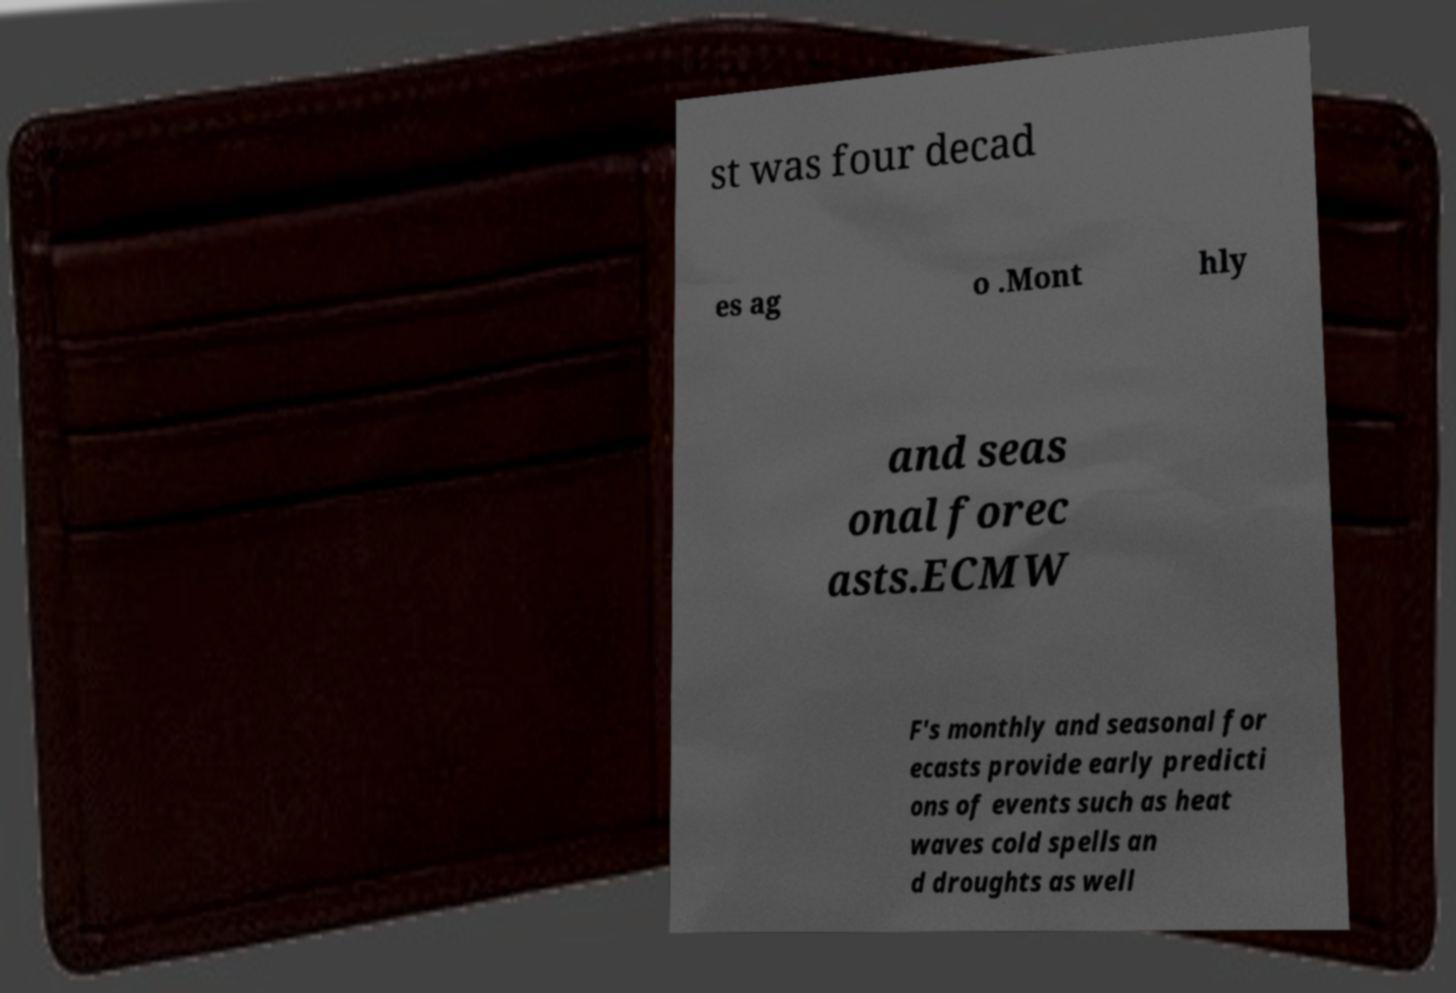Please identify and transcribe the text found in this image. st was four decad es ag o .Mont hly and seas onal forec asts.ECMW F's monthly and seasonal for ecasts provide early predicti ons of events such as heat waves cold spells an d droughts as well 